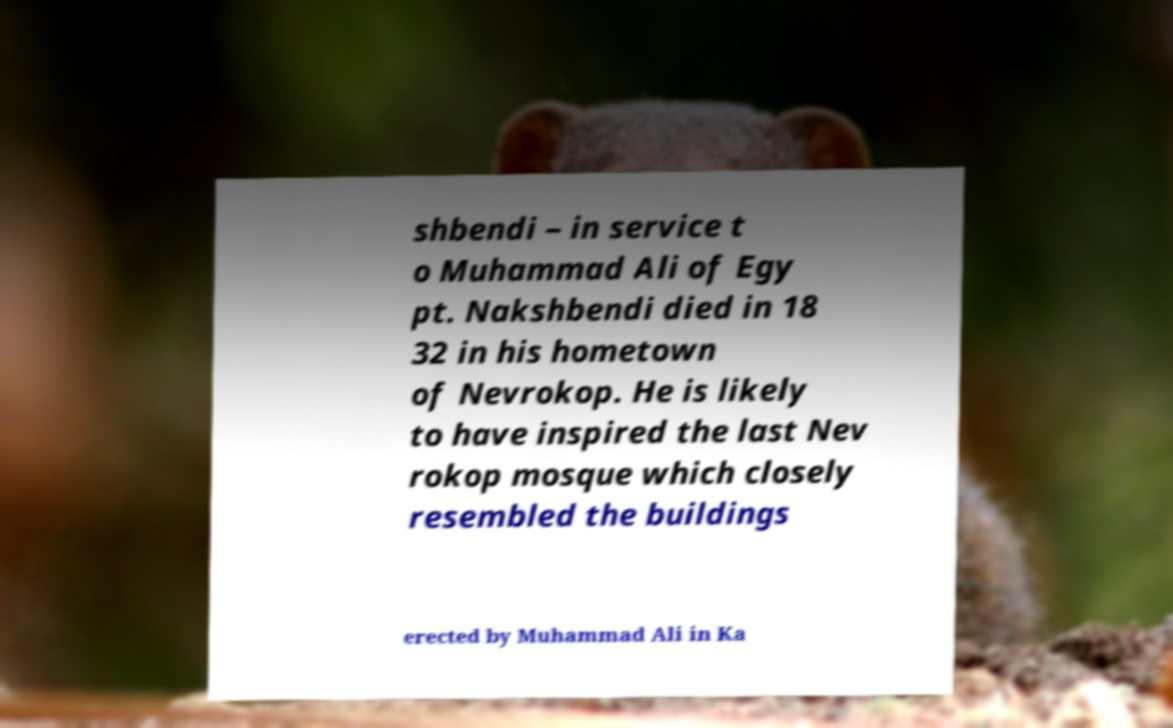Could you assist in decoding the text presented in this image and type it out clearly? shbendi – in service t o Muhammad Ali of Egy pt. Nakshbendi died in 18 32 in his hometown of Nevrokop. He is likely to have inspired the last Nev rokop mosque which closely resembled the buildings erected by Muhammad Ali in Ka 